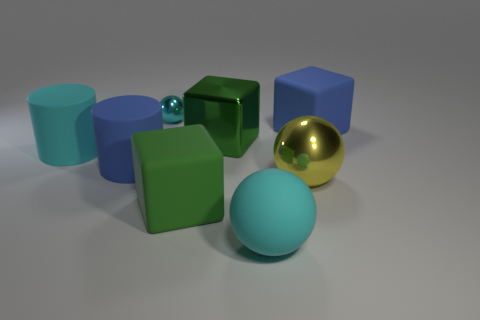There is a large blue thing that is right of the shiny thing in front of the cyan matte cylinder; what is its shape?
Keep it short and to the point. Cube. What shape is the tiny cyan thing?
Offer a very short reply. Sphere. What is the material of the blue cylinder that is in front of the blue thing behind the cyan object that is left of the tiny cyan sphere?
Provide a succinct answer. Rubber. What number of other objects are there of the same material as the large cyan sphere?
Keep it short and to the point. 4. How many blue matte cubes are in front of the large block that is right of the green metallic object?
Make the answer very short. 0. What number of cylinders are big things or tiny purple matte things?
Your answer should be compact. 2. The sphere that is on the left side of the large yellow thing and in front of the small metal sphere is what color?
Your response must be concise. Cyan. Is there any other thing that is the same color as the large shiny ball?
Provide a short and direct response. No. What color is the shiny sphere that is to the left of the cyan ball in front of the blue matte cube?
Offer a very short reply. Cyan. Do the cyan rubber cylinder and the green rubber thing have the same size?
Ensure brevity in your answer.  Yes. 